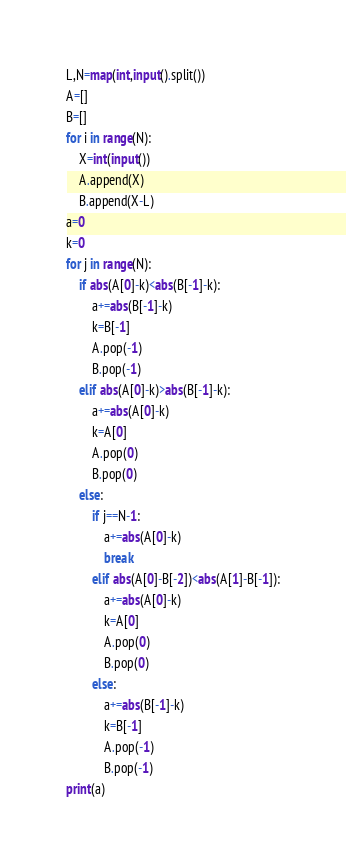<code> <loc_0><loc_0><loc_500><loc_500><_Python_>L,N=map(int,input().split())
A=[]
B=[]
for i in range(N):
    X=int(input())
    A.append(X)
    B.append(X-L)
a=0
k=0
for j in range(N):
    if abs(A[0]-k)<abs(B[-1]-k):
        a+=abs(B[-1]-k)
        k=B[-1]
        A.pop(-1)
        B.pop(-1)
    elif abs(A[0]-k)>abs(B[-1]-k):
        a+=abs(A[0]-k)
        k=A[0]
        A.pop(0)
        B.pop(0)
    else:
        if j==N-1:
            a+=abs(A[0]-k)
            break
        elif abs(A[0]-B[-2])<abs(A[1]-B[-1]):
            a+=abs(A[0]-k)
            k=A[0]
            A.pop(0)
            B.pop(0)
        else:
            a+=abs(B[-1]-k)
            k=B[-1]
            A.pop(-1)
            B.pop(-1)
print(a)</code> 